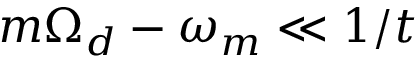Convert formula to latex. <formula><loc_0><loc_0><loc_500><loc_500>m \Omega _ { d } - \omega _ { m } \ll 1 / t</formula> 